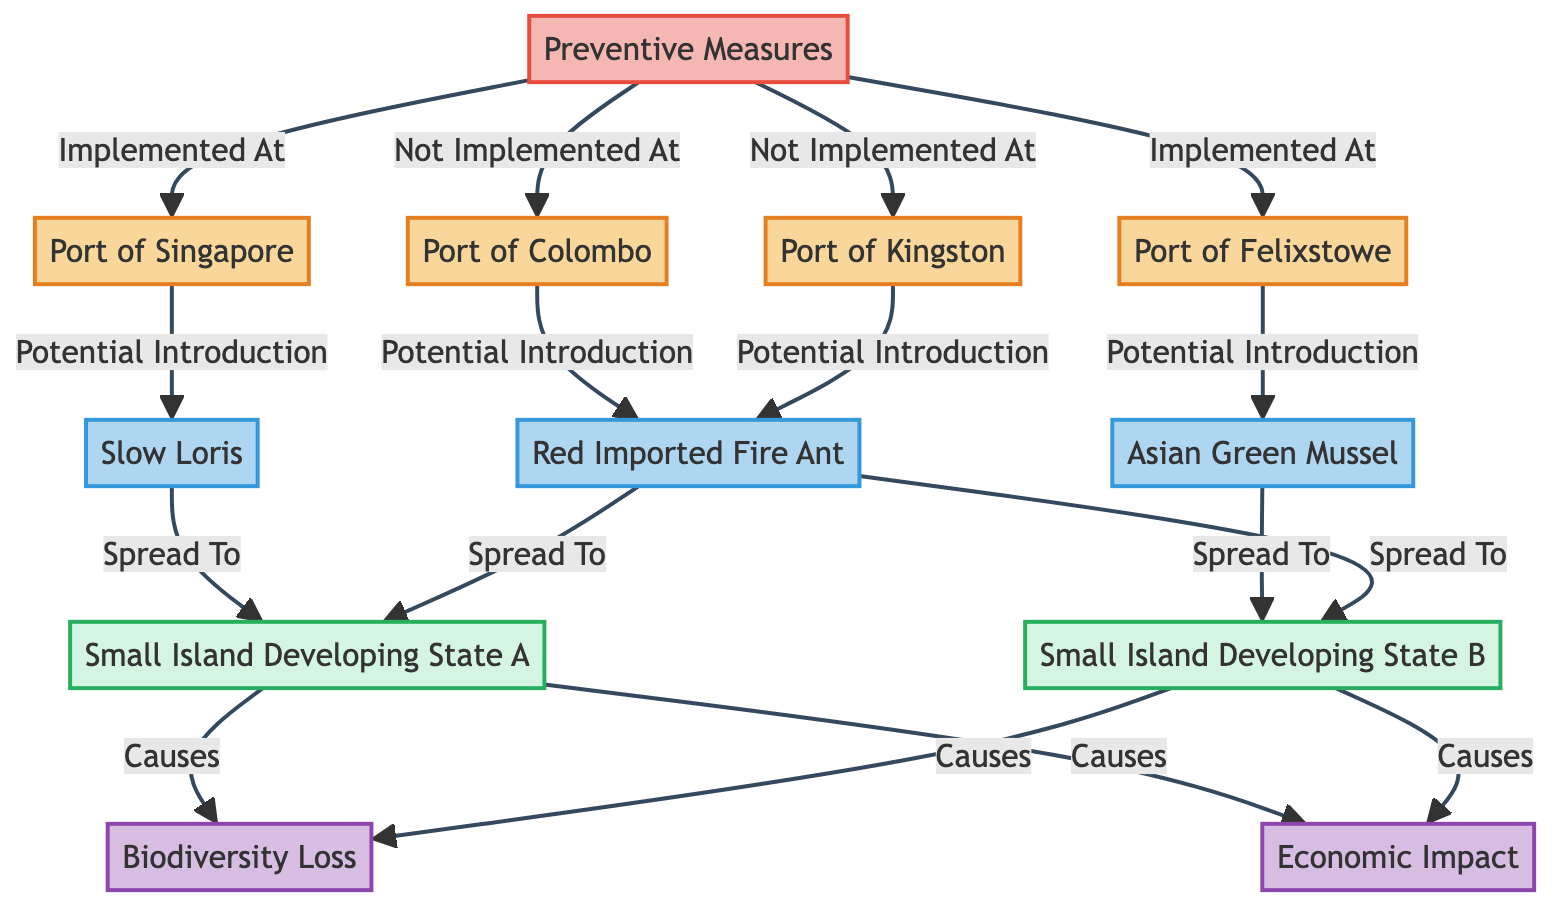What types of nodes are present in the diagram? The diagram includes four types of nodes: Ports, Invasive Species, Regions, and Impacts. Each type can be identified based on their distinct classifications in the diagram.
Answer: Ports, Invasive Species, Regions, Impacts How many invasive species are introduced via maritime trade networks? There are three invasive species identified in the diagram: Slow Loris, Red Imported Fire Ant, and Asian Green Mussel. Therefore, the total count is three.
Answer: 3 Which port is associated with the Slow Loris? According to the edges represented in the diagram, the port associated with the Slow Loris is the Port of Singapore, since it has a direct edge indicating potential introduction of this species.
Answer: Port of Singapore What is the relationship between the Port of Colombo and the Red Imported Fire Ant? The relationship is "Potential Introduction," as depicted by the directed edge connecting the Port of Colombo to the Red Imported Fire Ant in the diagram.
Answer: Potential Introduction Which small island developing state is affected by the economic impact of invasive species? Both Small Island Developing State A and Small Island Developing State B are affected by the economic impact, as indicated by their connections to the Economic Impact node through edges labeled "Causes."
Answer: Small Island Developing State A and Small Island Developing State B How many ports have implemented preventive measures? The diagram shows that two ports have implemented preventive measures, which are the Port of Singapore and the Port of Felixstowe.
Answer: 2 What invasive species spreads to Small Island Developing State B? The invasive species that spreads to Small Island Developing State B is the Asian Green Mussel, as indicated by the directed edge from the species to the region in the diagram.
Answer: Asian Green Mussel What are the consequences of invasive species spread to Small Island Developing State A? The consequences of invasive species spread to Small Island Developing State A lead to Biodiversity Loss and Economic Impact, both causing edges are directed from this region to the respective impact nodes.
Answer: Biodiversity Loss and Economic Impact Which ports have not implemented preventive measures according to the diagram? The ports that have not implemented preventive measures are the Port of Colombo and the Port of Kingston, as specified in the relationship edges from Preventive Measures to these ports.
Answer: Port of Colombo and Port of Kingston 